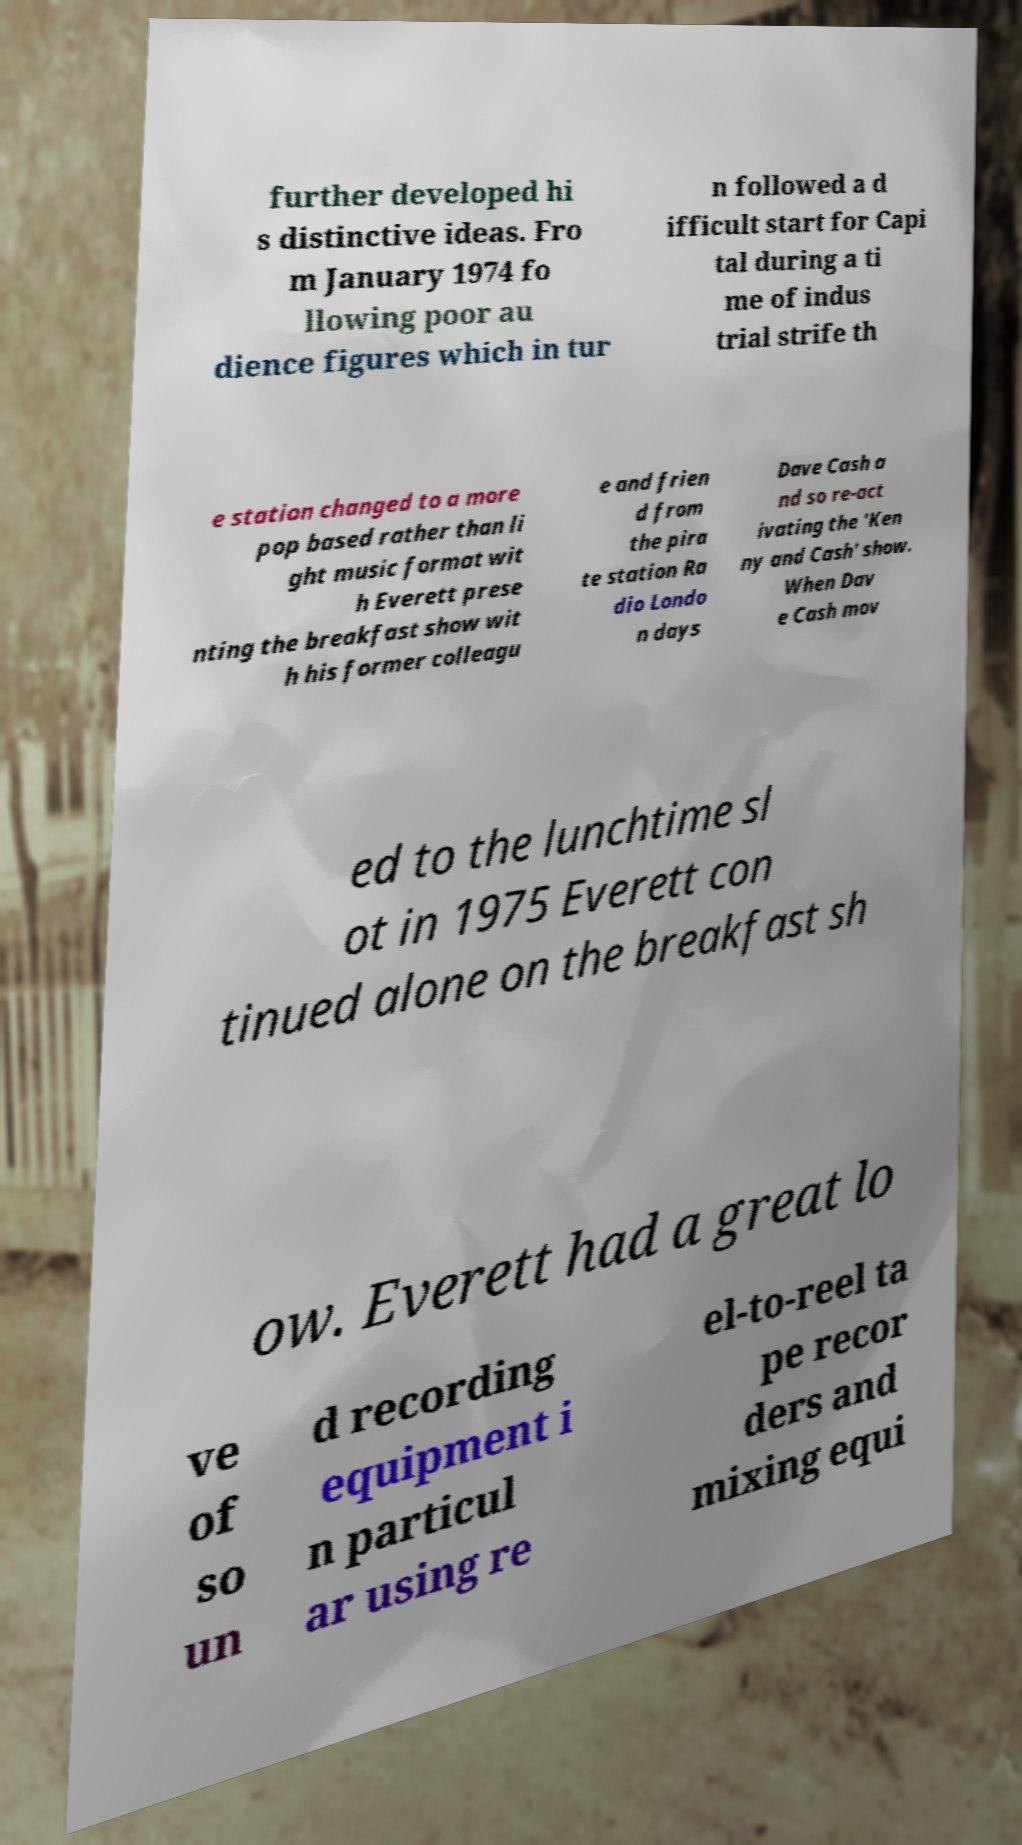What messages or text are displayed in this image? I need them in a readable, typed format. further developed hi s distinctive ideas. Fro m January 1974 fo llowing poor au dience figures which in tur n followed a d ifficult start for Capi tal during a ti me of indus trial strife th e station changed to a more pop based rather than li ght music format wit h Everett prese nting the breakfast show wit h his former colleagu e and frien d from the pira te station Ra dio Londo n days Dave Cash a nd so re-act ivating the 'Ken ny and Cash' show. When Dav e Cash mov ed to the lunchtime sl ot in 1975 Everett con tinued alone on the breakfast sh ow. Everett had a great lo ve of so un d recording equipment i n particul ar using re el-to-reel ta pe recor ders and mixing equi 